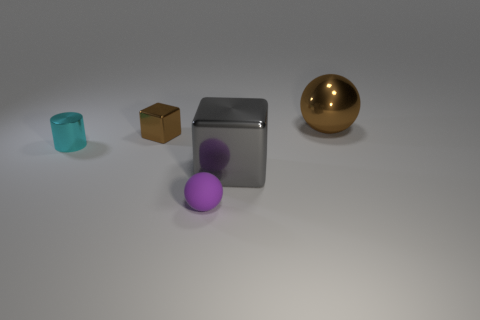Add 5 brown objects. How many objects exist? 10 Subtract all balls. How many objects are left? 3 Subtract all tiny blue rubber blocks. Subtract all gray metal blocks. How many objects are left? 4 Add 5 brown balls. How many brown balls are left? 6 Add 5 cyan metal cubes. How many cyan metal cubes exist? 5 Subtract 0 green cylinders. How many objects are left? 5 